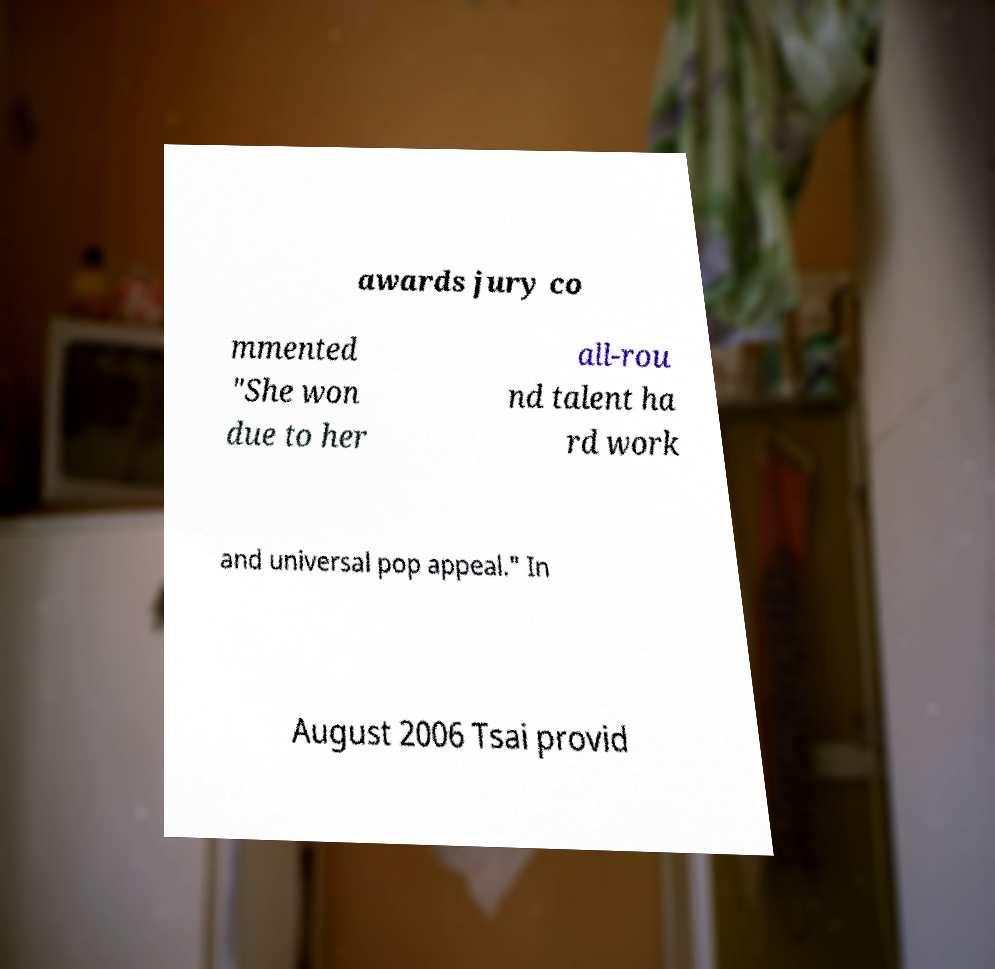Could you assist in decoding the text presented in this image and type it out clearly? awards jury co mmented "She won due to her all-rou nd talent ha rd work and universal pop appeal." In August 2006 Tsai provid 